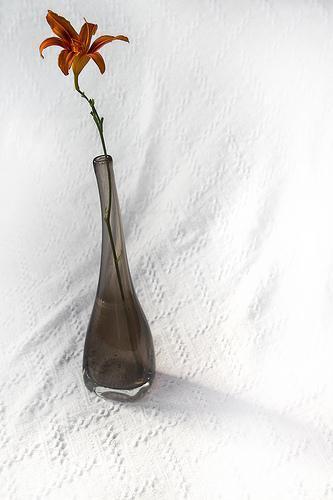How many flowers are in the vase?
Give a very brief answer. 1. How many different types of flowers are featured?
Give a very brief answer. 1. 